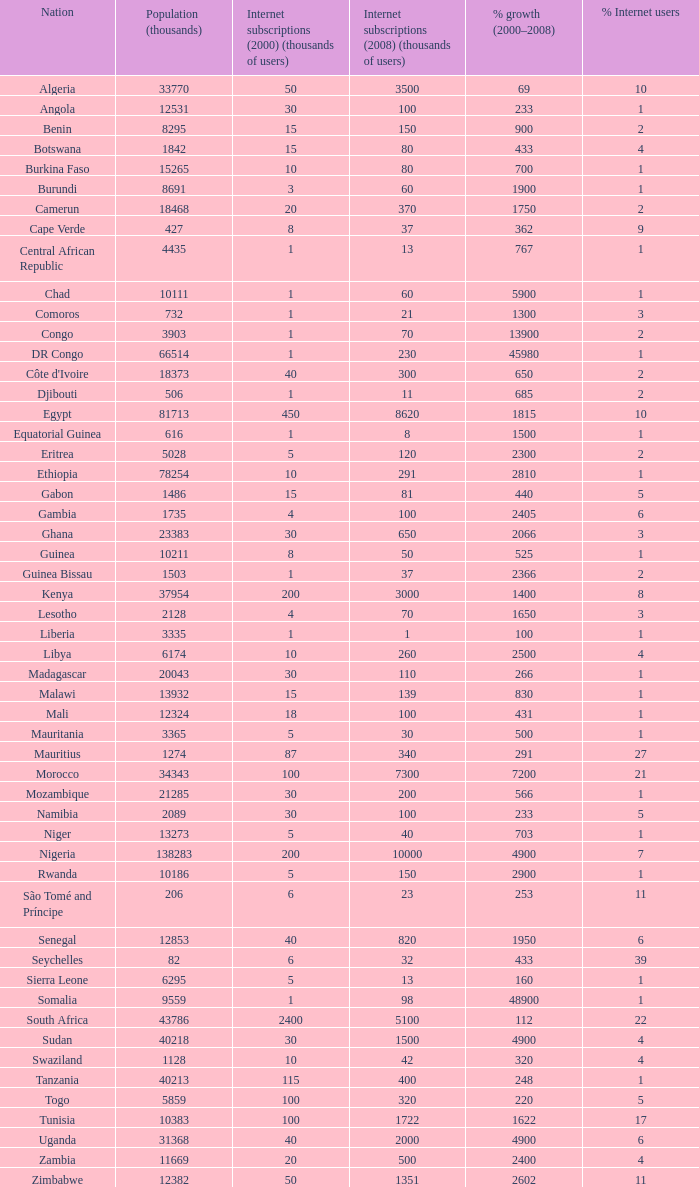What is the overall percentage increase in uganda's growth from 2000 to 2008? 1.0. 